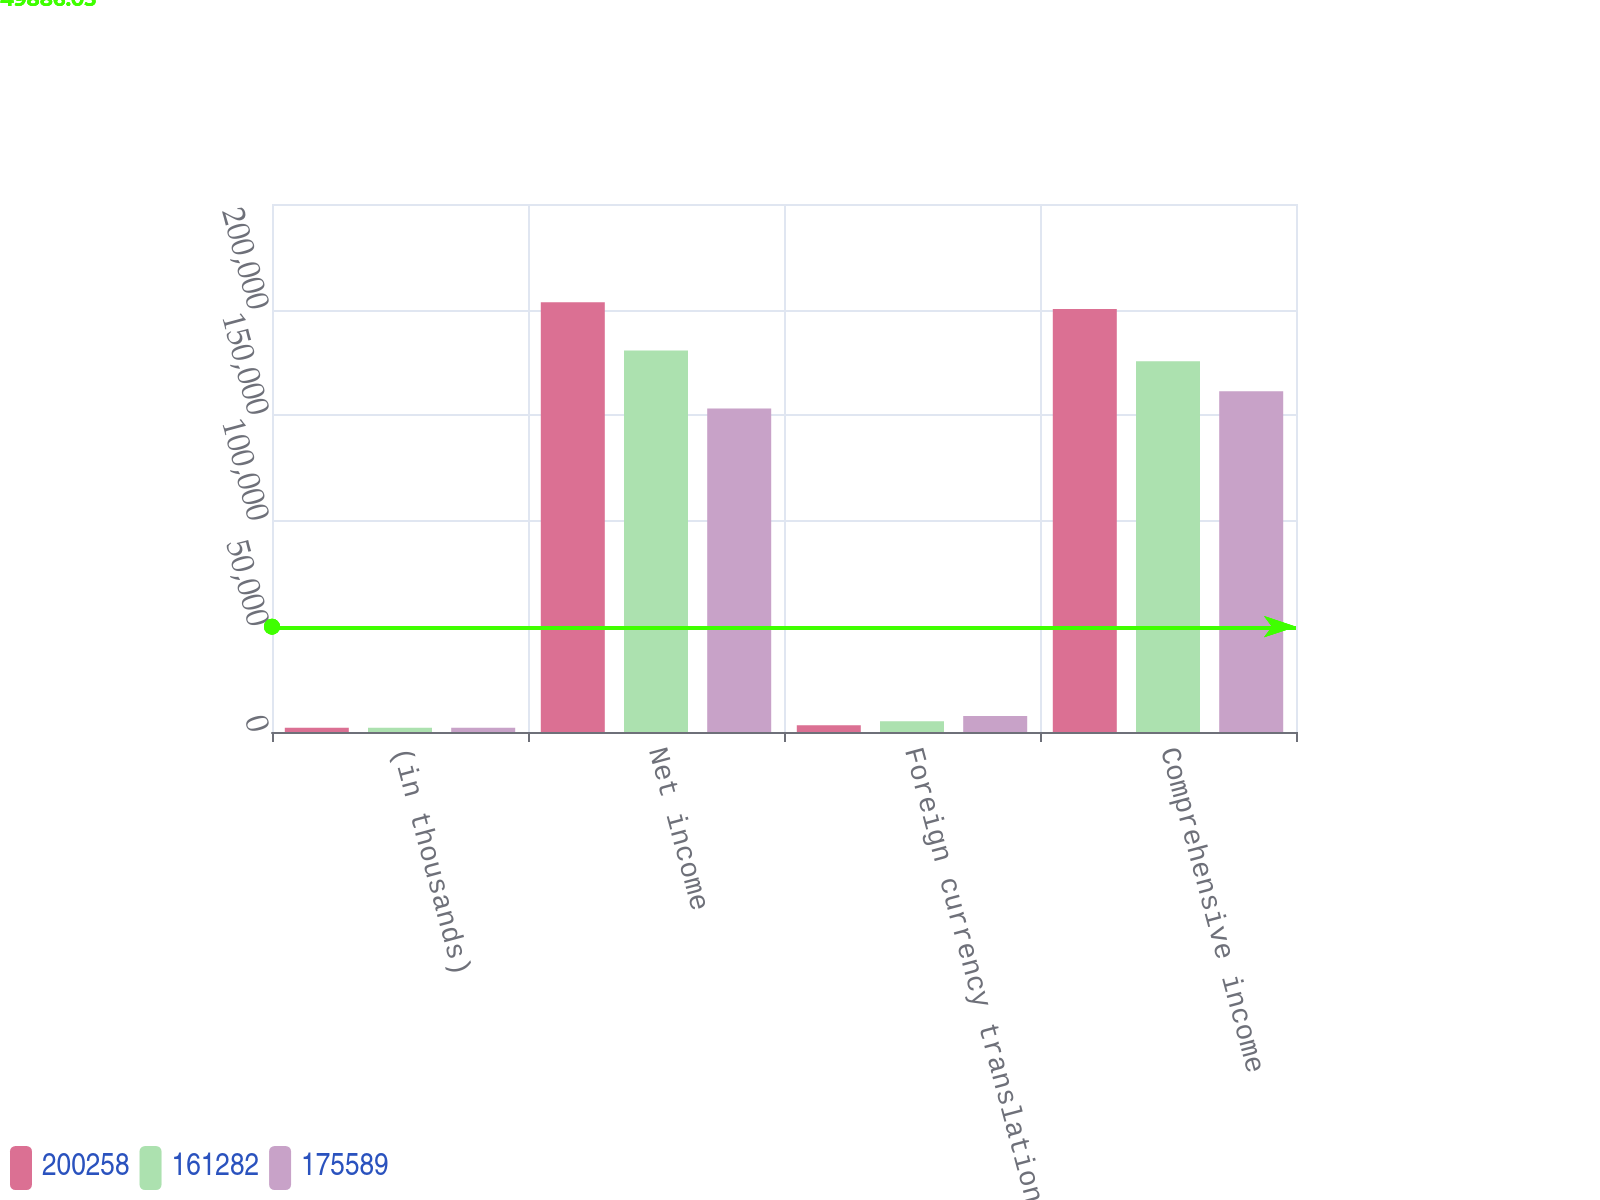Convert chart. <chart><loc_0><loc_0><loc_500><loc_500><stacked_bar_chart><ecel><fcel>(in thousands)<fcel>Net income<fcel>Foreign currency translation<fcel>Comprehensive income<nl><fcel>200258<fcel>2012<fcel>203483<fcel>3225<fcel>200258<nl><fcel>161282<fcel>2011<fcel>180675<fcel>5086<fcel>175589<nl><fcel>175589<fcel>2010<fcel>153132<fcel>7618<fcel>161282<nl></chart> 